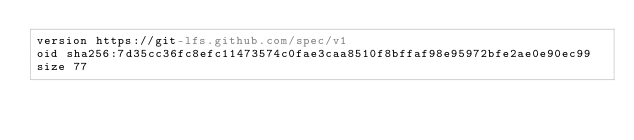<code> <loc_0><loc_0><loc_500><loc_500><_YAML_>version https://git-lfs.github.com/spec/v1
oid sha256:7d35cc36fc8efc11473574c0fae3caa8510f8bffaf98e95972bfe2ae0e90ec99
size 77
</code> 